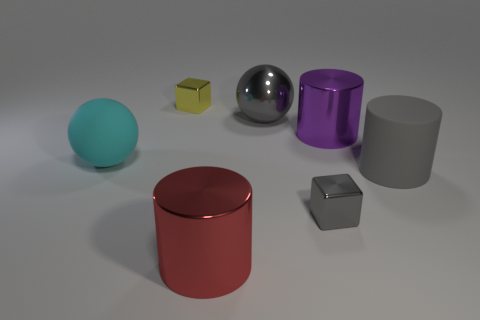How many objects are either large shiny objects or big rubber balls?
Provide a succinct answer. 4. Do the big gray shiny object and the purple metallic thing have the same shape?
Give a very brief answer. No. Are there any big cylinders made of the same material as the big purple thing?
Provide a succinct answer. Yes. There is a large cylinder that is behind the rubber sphere; are there any gray rubber objects that are to the left of it?
Your response must be concise. No. Does the metallic block that is in front of the matte ball have the same size as the large gray rubber cylinder?
Your answer should be very brief. No. What is the size of the yellow cube?
Provide a short and direct response. Small. Are there any metal things of the same color as the large rubber cylinder?
Keep it short and to the point. Yes. How many tiny things are either yellow rubber things or gray matte objects?
Your answer should be compact. 0. There is a metallic object that is both left of the large gray ball and behind the tiny gray shiny thing; how big is it?
Provide a short and direct response. Small. There is a yellow metallic cube; what number of things are in front of it?
Offer a very short reply. 6. 